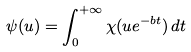Convert formula to latex. <formula><loc_0><loc_0><loc_500><loc_500>\psi ( u ) = \int _ { 0 } ^ { + \infty } \chi ( u e ^ { - b t } ) \, d t</formula> 